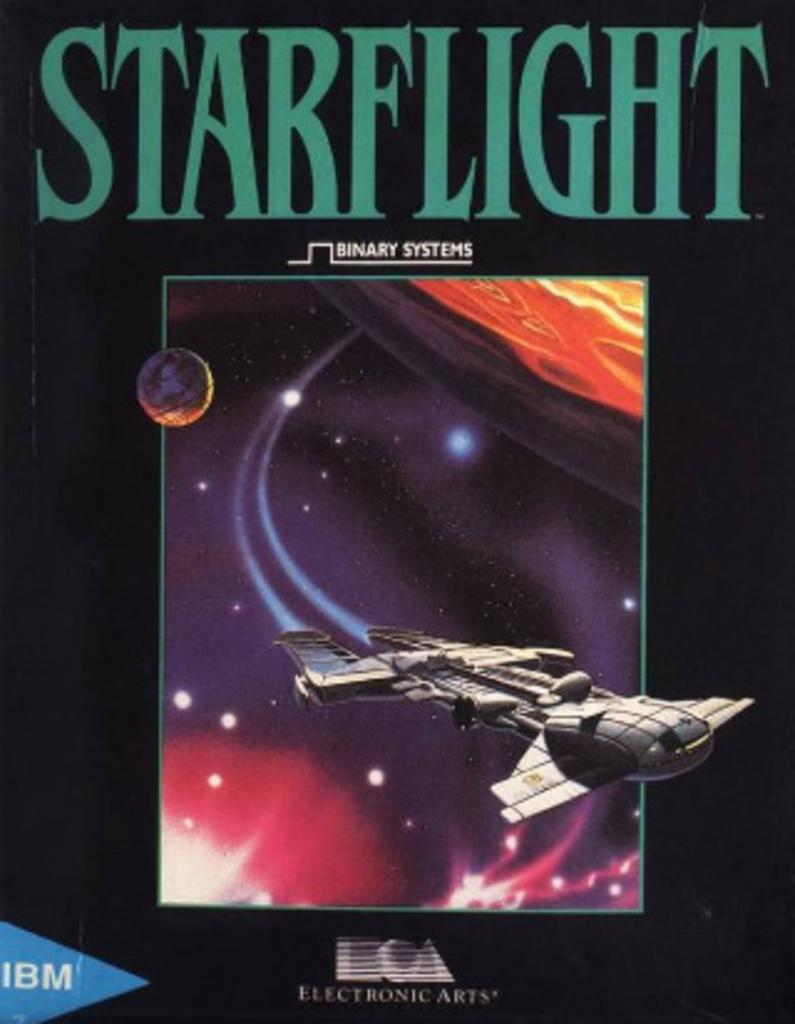<image>
Give a short and clear explanation of the subsequent image. A book cover with the title Starfilght with a picture of a spaceship 